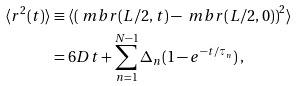<formula> <loc_0><loc_0><loc_500><loc_500>\langle r ^ { 2 } ( t ) \rangle & \equiv \langle \left ( \ m b { r } ( L / 2 , t ) - \ m b { r } ( L / 2 , 0 ) \right ) ^ { 2 } \rangle \\ & = 6 D t + \sum _ { n = 1 } ^ { N - 1 } \Delta _ { n } ( 1 - e ^ { - t / \tau _ { n } } ) \, ,</formula> 